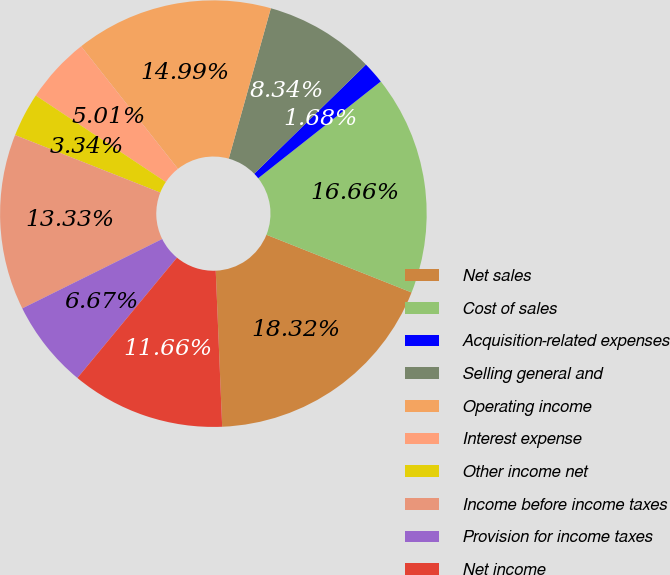Convert chart. <chart><loc_0><loc_0><loc_500><loc_500><pie_chart><fcel>Net sales<fcel>Cost of sales<fcel>Acquisition-related expenses<fcel>Selling general and<fcel>Operating income<fcel>Interest expense<fcel>Other income net<fcel>Income before income taxes<fcel>Provision for income taxes<fcel>Net income<nl><fcel>18.32%<fcel>16.66%<fcel>1.68%<fcel>8.34%<fcel>14.99%<fcel>5.01%<fcel>3.34%<fcel>13.33%<fcel>6.67%<fcel>11.66%<nl></chart> 